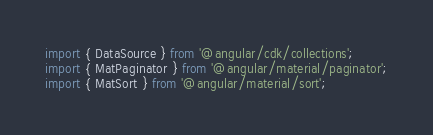Convert code to text. <code><loc_0><loc_0><loc_500><loc_500><_TypeScript_>import { DataSource } from '@angular/cdk/collections';
import { MatPaginator } from '@angular/material/paginator';
import { MatSort } from '@angular/material/sort';</code> 